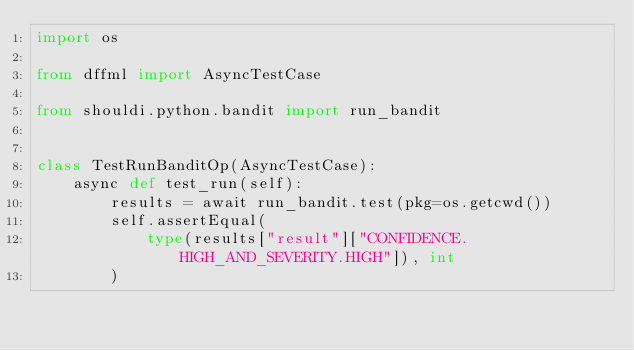Convert code to text. <code><loc_0><loc_0><loc_500><loc_500><_Python_>import os

from dffml import AsyncTestCase

from shouldi.python.bandit import run_bandit


class TestRunBanditOp(AsyncTestCase):
    async def test_run(self):
        results = await run_bandit.test(pkg=os.getcwd())
        self.assertEqual(
            type(results["result"]["CONFIDENCE.HIGH_AND_SEVERITY.HIGH"]), int
        )
</code> 